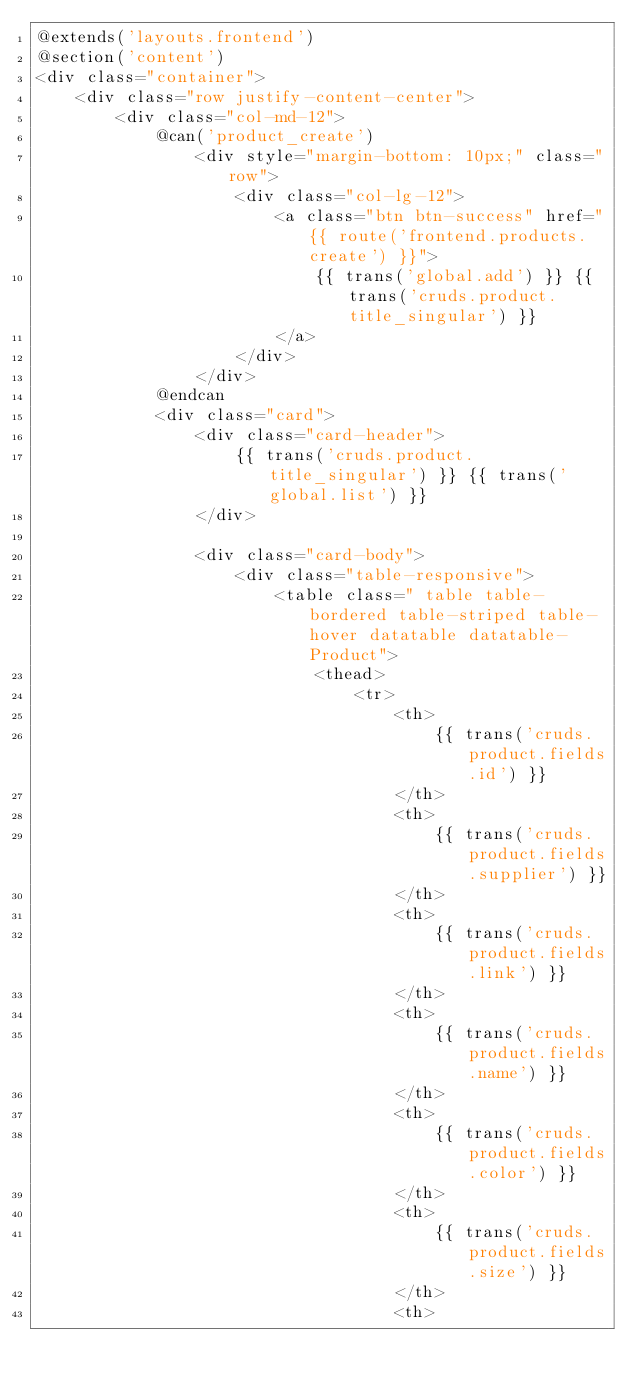Convert code to text. <code><loc_0><loc_0><loc_500><loc_500><_PHP_>@extends('layouts.frontend')
@section('content')
<div class="container">
    <div class="row justify-content-center">
        <div class="col-md-12">
            @can('product_create')
                <div style="margin-bottom: 10px;" class="row">
                    <div class="col-lg-12">
                        <a class="btn btn-success" href="{{ route('frontend.products.create') }}">
                            {{ trans('global.add') }} {{ trans('cruds.product.title_singular') }}
                        </a>
                    </div>
                </div>
            @endcan
            <div class="card">
                <div class="card-header">
                    {{ trans('cruds.product.title_singular') }} {{ trans('global.list') }}
                </div>

                <div class="card-body">
                    <div class="table-responsive">
                        <table class=" table table-bordered table-striped table-hover datatable datatable-Product">
                            <thead>
                                <tr>
                                    <th>
                                        {{ trans('cruds.product.fields.id') }}
                                    </th>
                                    <th>
                                        {{ trans('cruds.product.fields.supplier') }}
                                    </th>
                                    <th>
                                        {{ trans('cruds.product.fields.link') }}
                                    </th>
                                    <th>
                                        {{ trans('cruds.product.fields.name') }}
                                    </th>
                                    <th>
                                        {{ trans('cruds.product.fields.color') }}
                                    </th>
                                    <th>
                                        {{ trans('cruds.product.fields.size') }}
                                    </th>
                                    <th></code> 